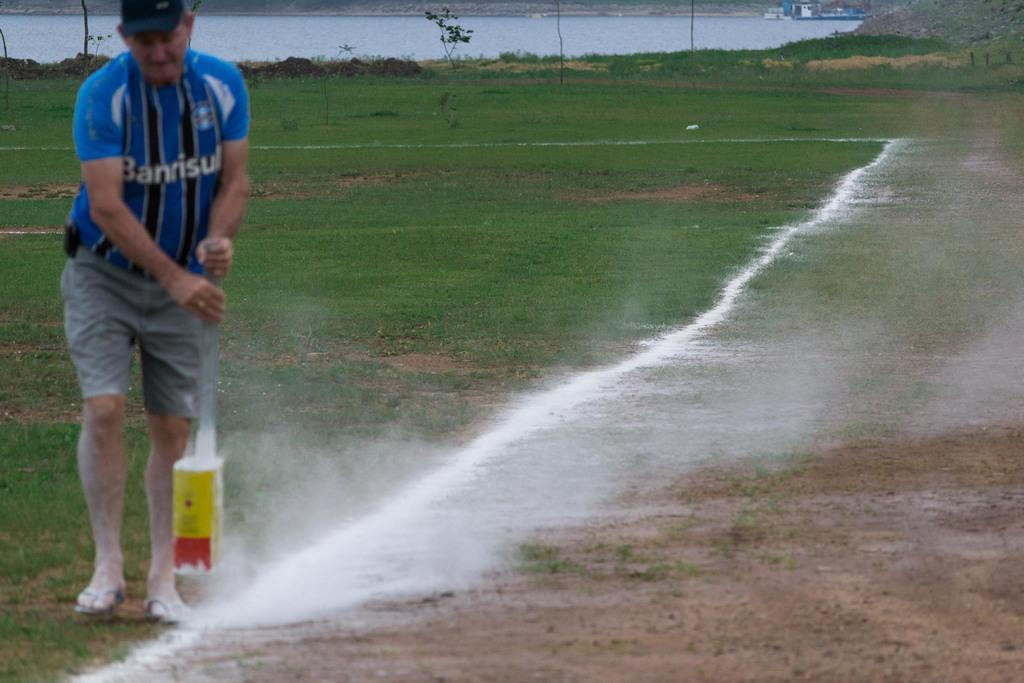<image>
Offer a succinct explanation of the picture presented. A guy with a shirt that has the word Banrisul on it 